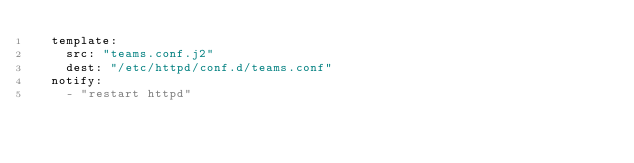Convert code to text. <code><loc_0><loc_0><loc_500><loc_500><_YAML_>  template:
    src: "teams.conf.j2"
    dest: "/etc/httpd/conf.d/teams.conf"
  notify:
    - "restart httpd"
</code> 